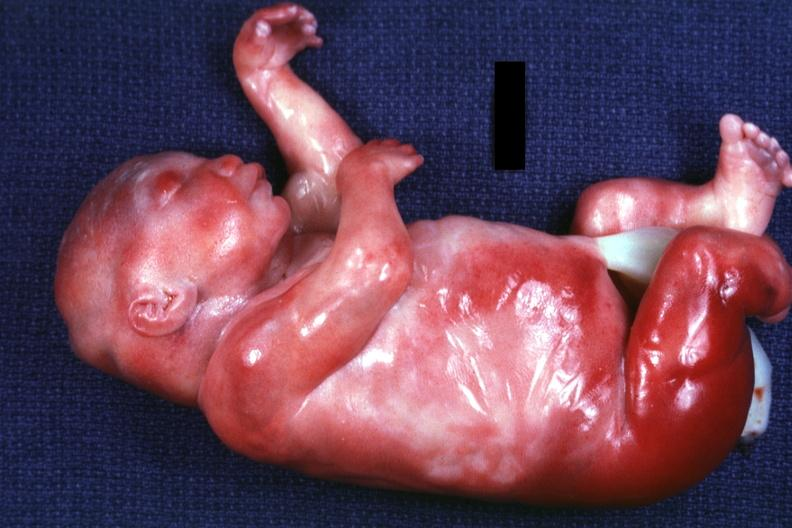what do a barely seen vascular mass extruding from occipital region of skull arms and legs appear?
Answer the question using a single word or phrase. Too short has six digits 